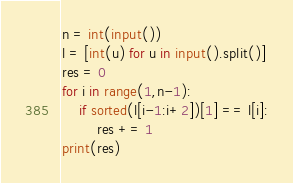<code> <loc_0><loc_0><loc_500><loc_500><_Python_>n = int(input())
l = [int(u) for u in input().split()]
res = 0
for i in range(1,n-1):
    if sorted(l[i-1:i+2])[1] == l[i]:
        res += 1
print(res)</code> 